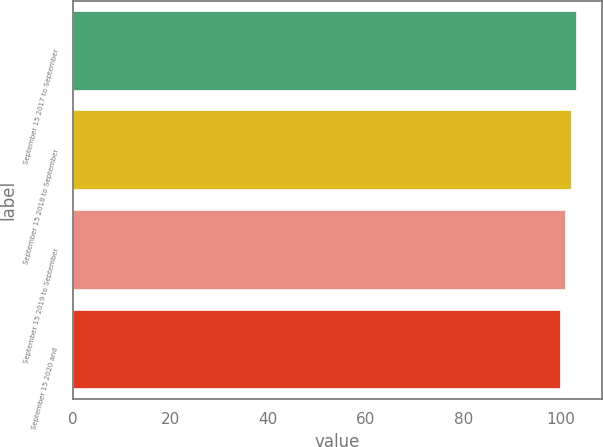<chart> <loc_0><loc_0><loc_500><loc_500><bar_chart><fcel>September 15 2017 to September<fcel>September 15 2018 to September<fcel>September 15 2019 to September<fcel>September 15 2020 and<nl><fcel>103.31<fcel>102.21<fcel>101.1<fcel>100<nl></chart> 